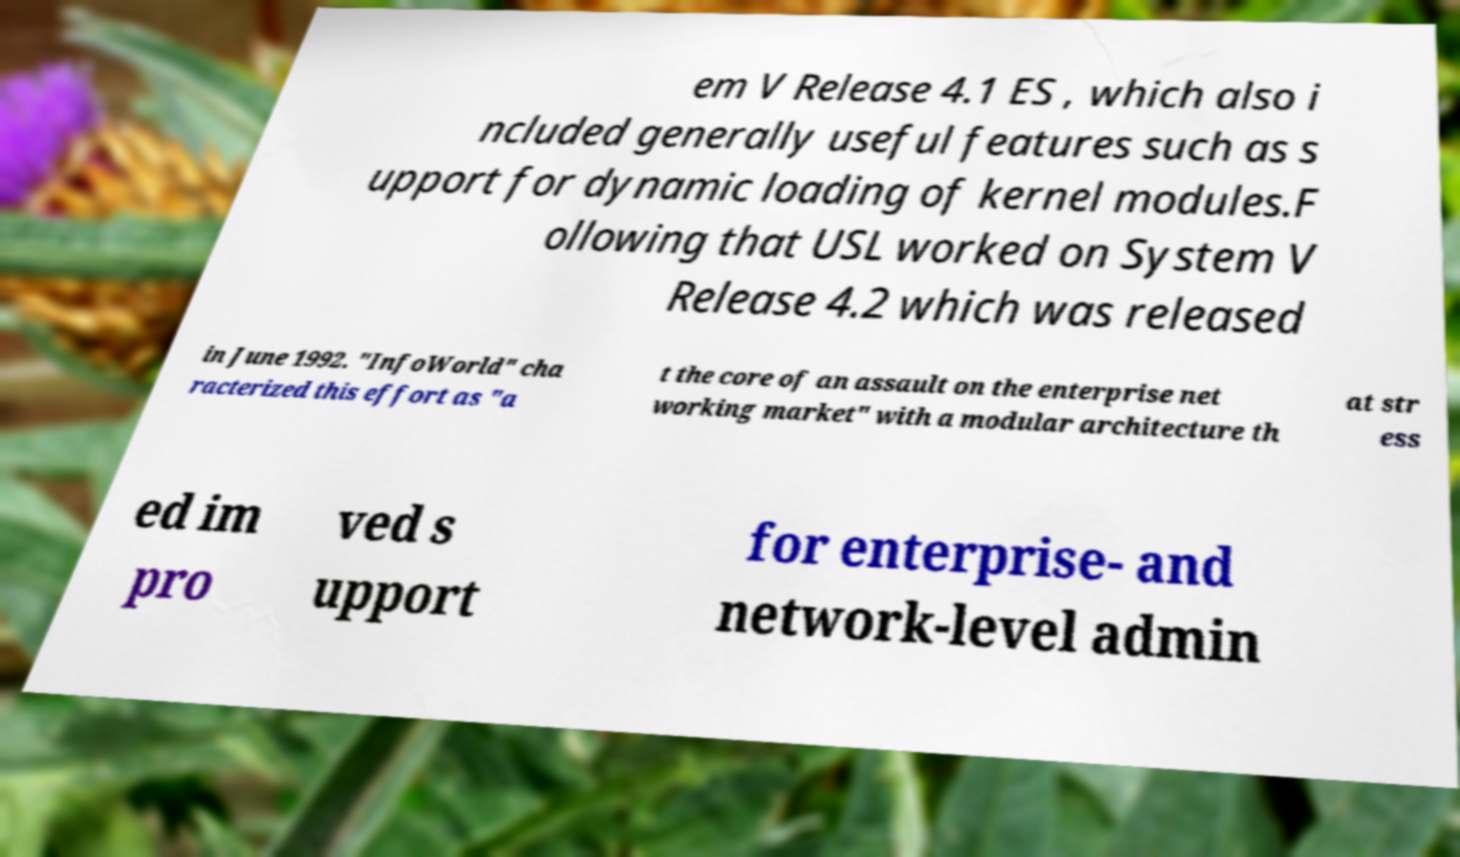There's text embedded in this image that I need extracted. Can you transcribe it verbatim? em V Release 4.1 ES , which also i ncluded generally useful features such as s upport for dynamic loading of kernel modules.F ollowing that USL worked on System V Release 4.2 which was released in June 1992. "InfoWorld" cha racterized this effort as "a t the core of an assault on the enterprise net working market" with a modular architecture th at str ess ed im pro ved s upport for enterprise- and network-level admin 